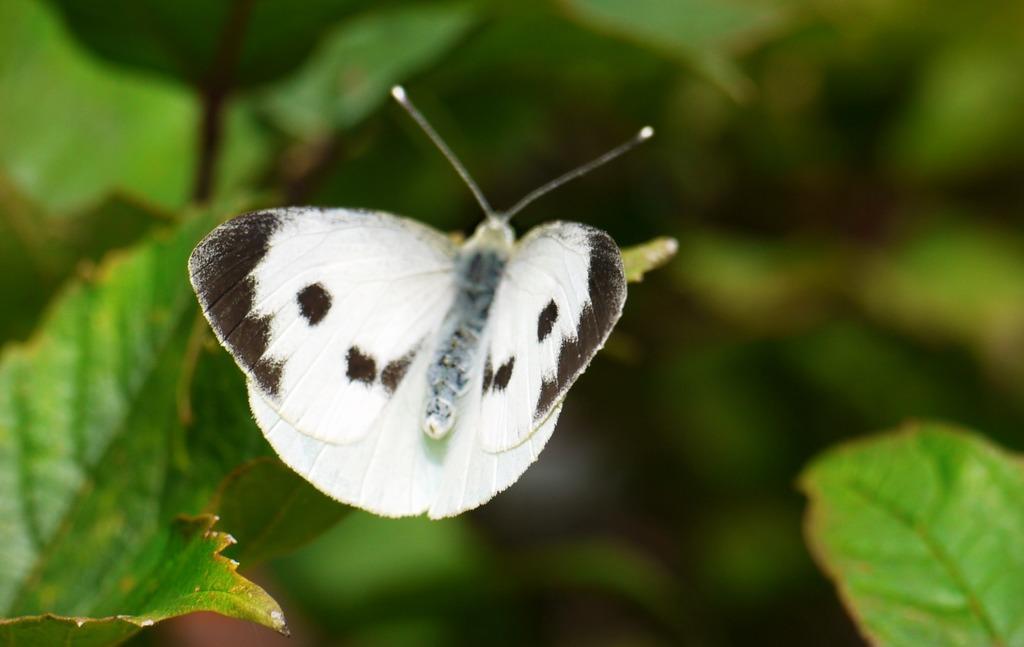Can you describe this image briefly? In this picture, there is a butterfly which is in black and white in color. Towards the left and right, there are leaves. 